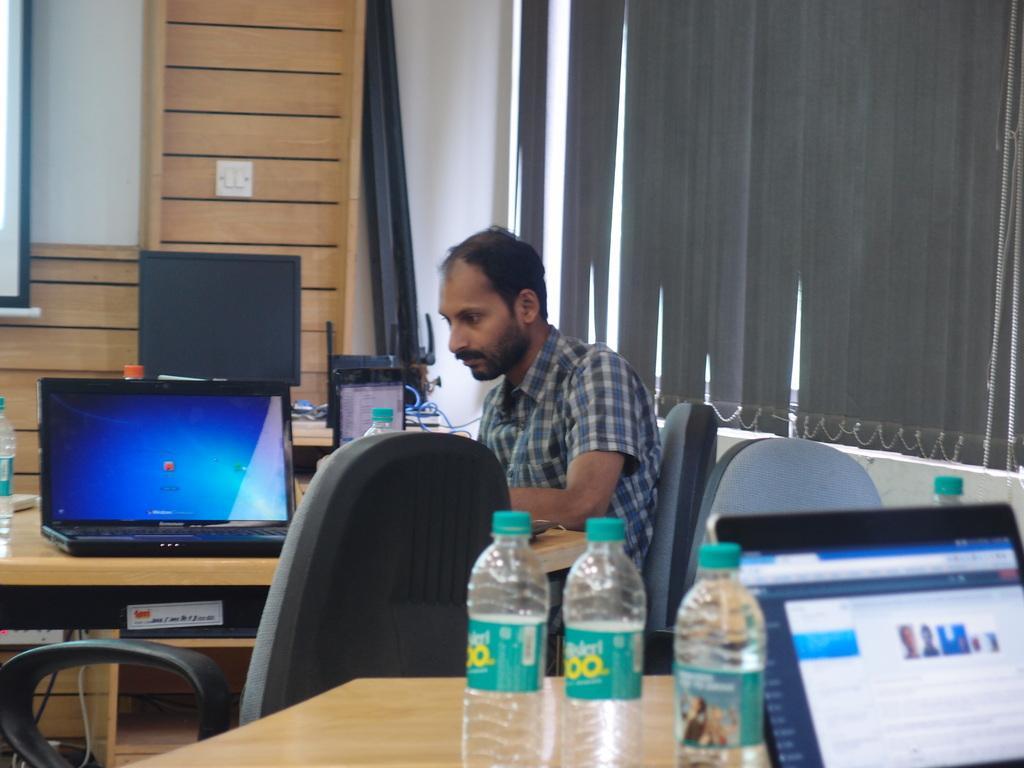Describe this image in one or two sentences. This is the picture of a man sitting on a chair. In front of the man there is a table on the table there are laptop, bottles. Background of the man is windows and a wooden wall. 